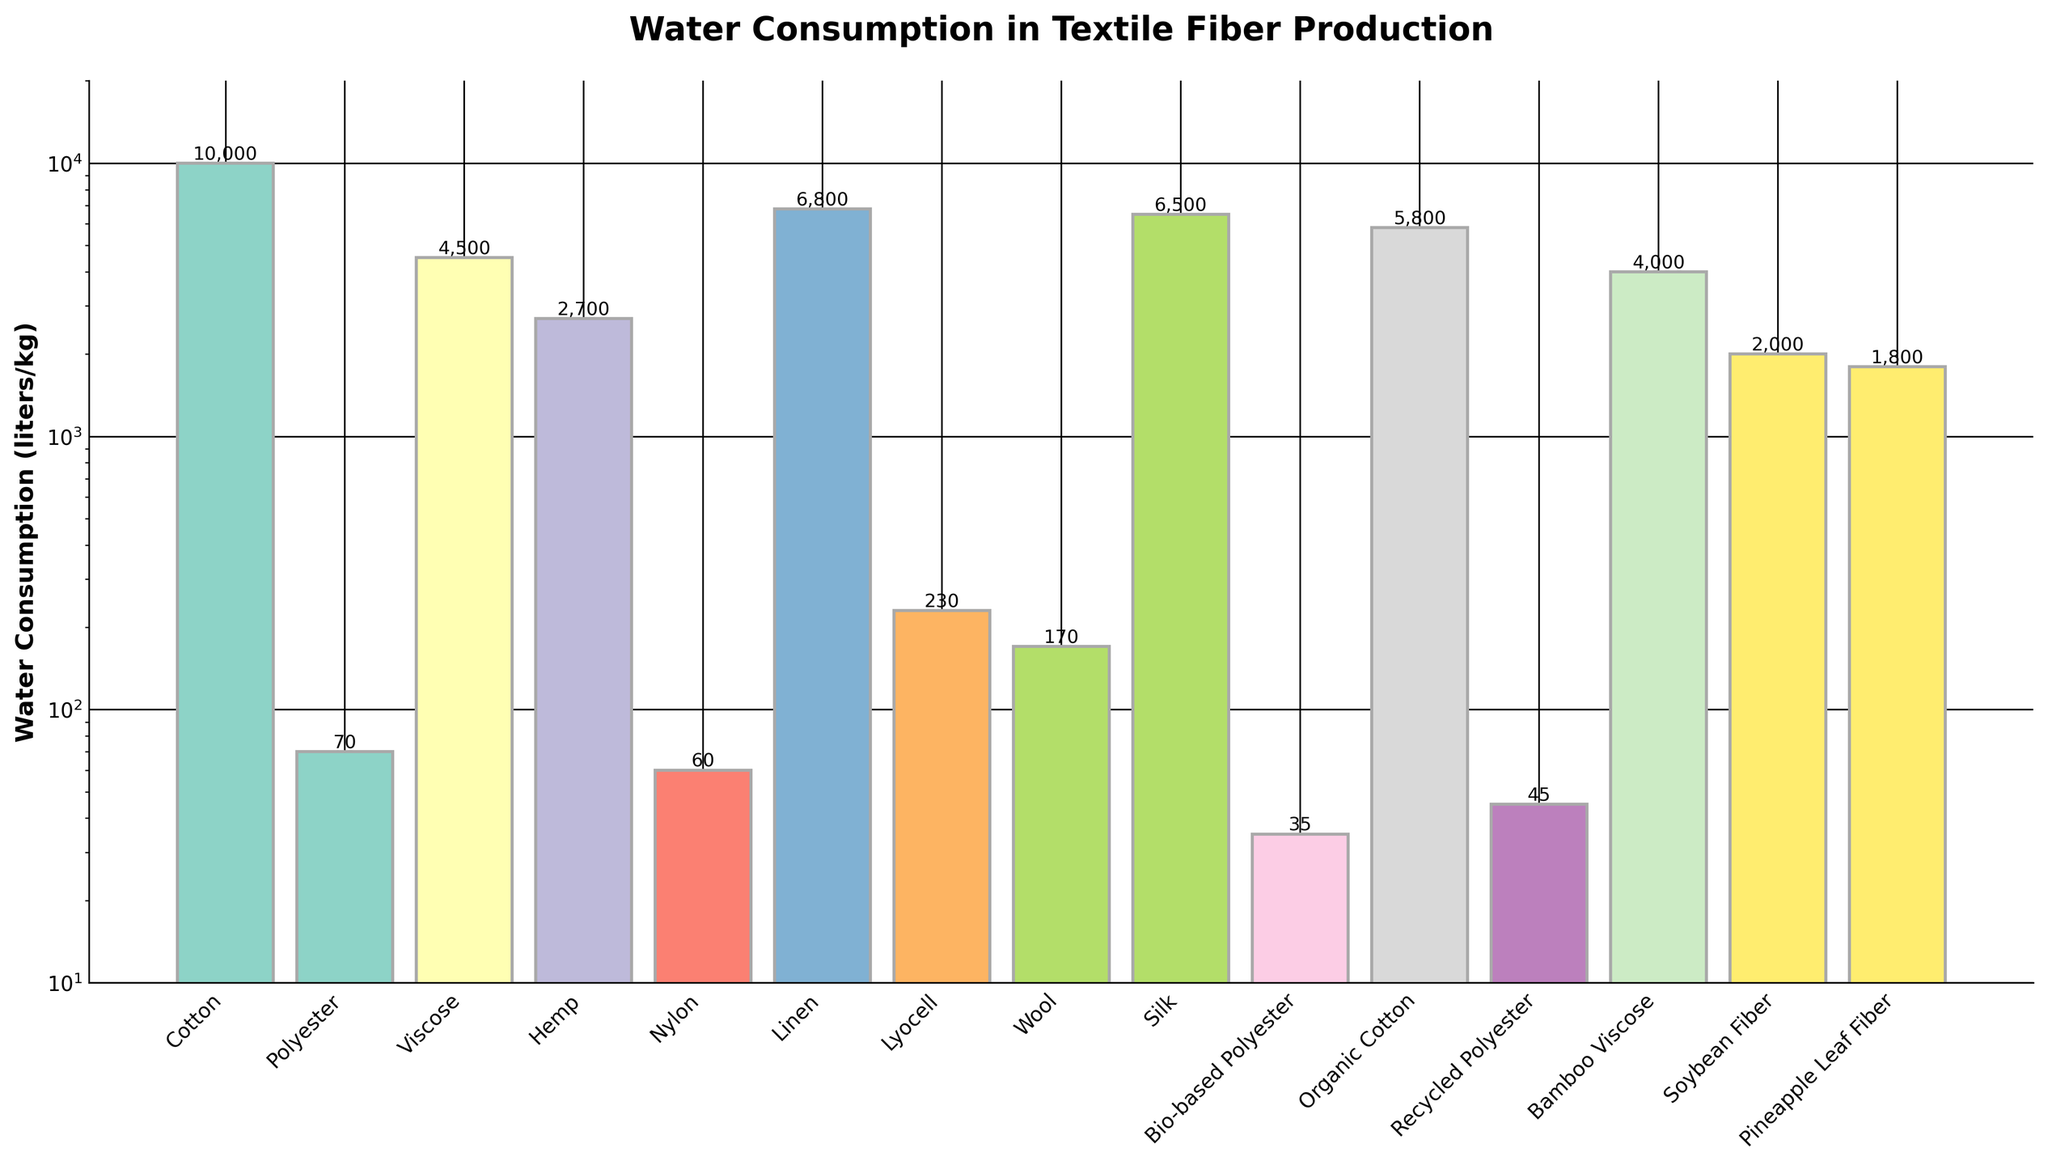Which fiber type has the highest water consumption? The fiber type with the highest bar indicates the highest water consumption. Cotton has the highest bar.
Answer: Cotton Which fiber type has the lowest water consumption? The fiber type with the lowest bar indicates the lowest water consumption. Nylon has the lowest bar.
Answer: Nylon How does the water consumption of Organic Cotton compare to Regular Cotton? Compare the heights of the bars for Organic Cotton and Cotton. Organic Cotton has a lower bar than Regular Cotton, indicating less water consumption.
Answer: Organic Cotton uses less water than Regular Cotton What is the water consumption difference between Hemp and Bamboo Viscose? Subtract the water consumption of Bamboo Viscose from Hemp. Hemp (2700 liters/kg) - Bamboo Viscose (4000 liters/kg) = -1300 liters/kg.
Answer: 1300 liters/kg less water for Hemp What is the average water consumption of the synthetic fibers shown (Polyester, Nylon, Bio-based Polyester, Recycled Polyester)? Add the water consumption of all synthetic fibers and divide by the number of synthetic fibers. (70 + 60 + 35 + 45) / 4 = 52.5 liters/kg.
Answer: 52.5 liters/kg Among bio-based fibers, which one uses the least water? Identify the bio-based fiber with the smallest bar height. Bio-based Polyester has the smallest height among bio-based options.
Answer: Bio-based Polyester Which two fibers have nearly equal water consumption? Compare the bar heights visually to find two fibers with close heights. Wool (170 liters/kg) and Lyocell (230 liters/kg) have nearly equal heights.
Answer: Wool and Lyocell Is the water consumption for Silk above or below the average of all fibers? Calculate the average of all fiber water consumption and compare it to the water consumption of Silk. Average = (10000 + 70 + 4500 + 2700 + 60 + 6800 + 230 + 170 + 6500 + 35 + 5800 + 45 + 4000 + 2000 + 1800) / 15 ≈ 4113 liters/kg. Silk (6500 liters/kg) is above this average.
Answer: Above What is the median water consumption among the listed textile fibers? Order the water consumption values and identify the middle value. The ordered list: [35, 45, 60, 70, 170, 230, 1800, 2000, 2700, 4000, 4500, 5800, 6500, 6800, 10000]. Median value is 2700 liters/kg.
Answer: 2700 liters/kg 